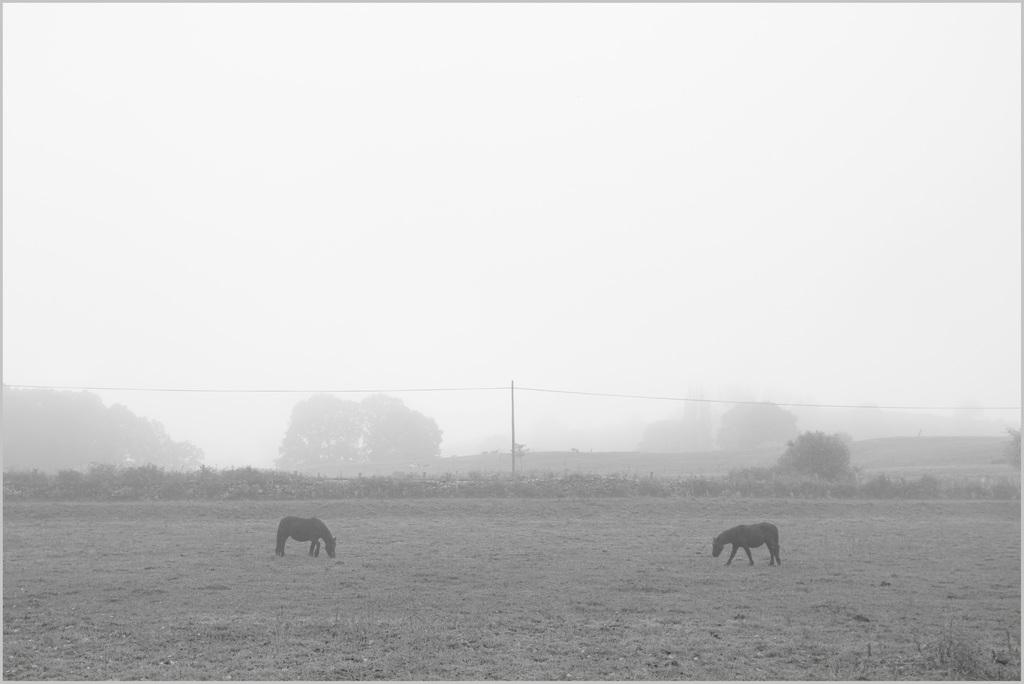What animals can be seen on the ground in the image? There are horses on the ground in the image. What type of natural environment is visible in the background of the image? There are trees, plants, and the sky visible in the background of the image. What man-made structures can be seen in the background of the image? There are poles with wires in the background of the image. What is the color scheme of the image? The image is black and white in color. Can you see your sister smiling while holding a loaf of bread in the image? There is no sister, smile, or bread present in the image. 